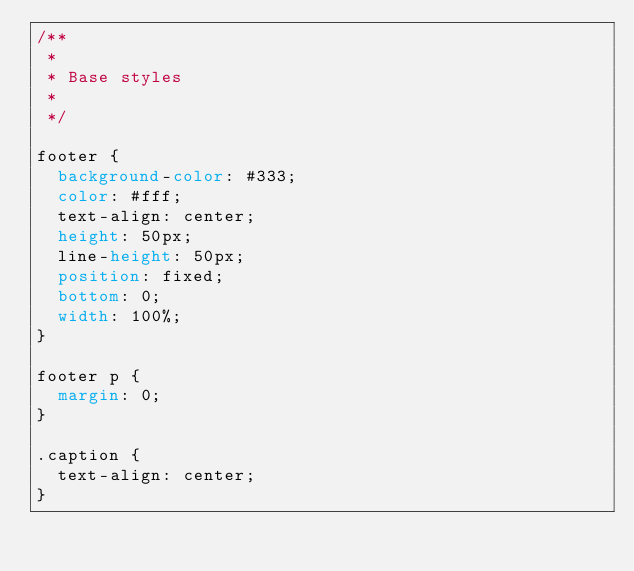<code> <loc_0><loc_0><loc_500><loc_500><_CSS_>/**
 *
 * Base styles
 *
 */

footer {
  background-color: #333;
  color: #fff;
  text-align: center;
  height: 50px;
  line-height: 50px;
  position: fixed;
  bottom: 0;
  width: 100%;
}

footer p {
  margin: 0;
}

.caption {
  text-align: center;
}
</code> 